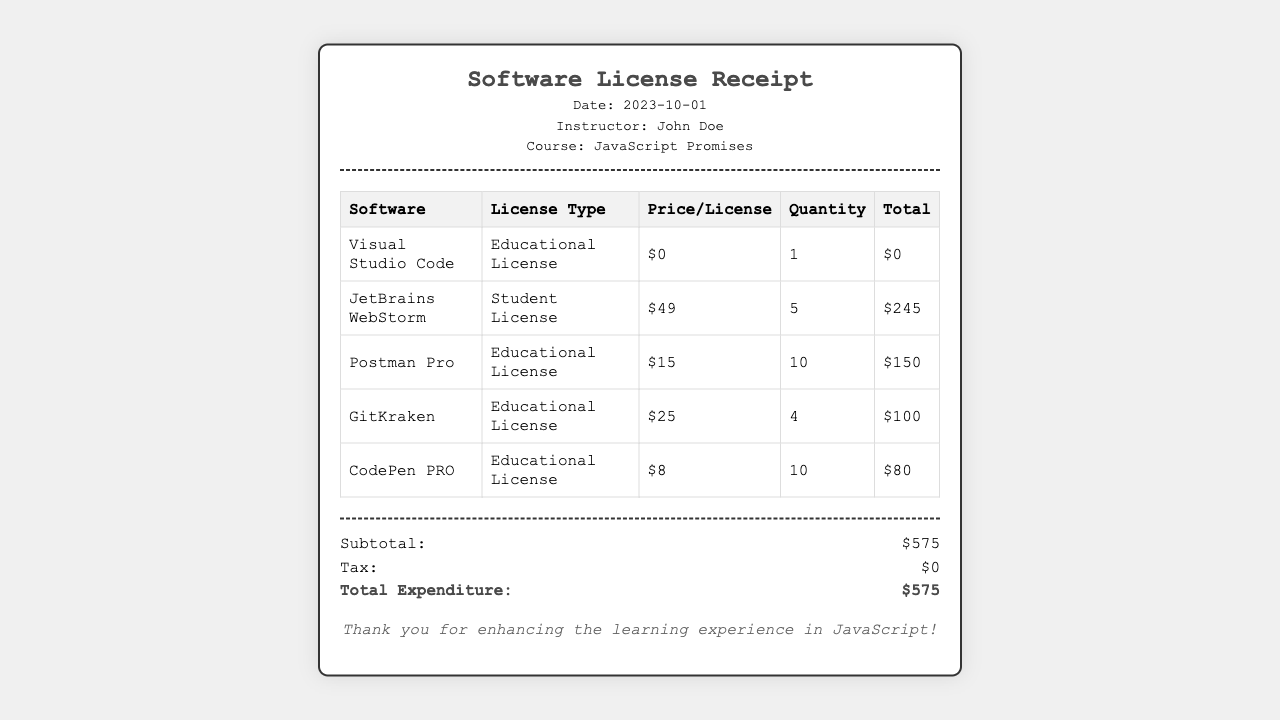what is the date of the receipt? The date is clearly stated in the header section of the document.
Answer: 2023-10-01 who is the instructor listed in the receipt? The instructor's name is displayed in the header of the receipt.
Answer: John Doe what is the total expenditure on software licenses? The total expenditure is calculated as the sum of all item totals and noted in the summary section.
Answer: $575 how many licenses of JetBrains WebStorm were purchased? The quantity of licenses is shown in the table under the respective software.
Answer: 5 what is the price per license for Postman Pro? The price per license for Postman Pro is listed in the table.
Answer: $15 which software has a price per license of $0? The software with no cost is mentioned in the table under the corresponding price column.
Answer: Visual Studio Code what is the subtotal of the purchases? The subtotal is provided as part of the summary details in the document.
Answer: $575 how many total CodePen PRO licenses were included in the purchase? The quantity is indicated in the relevant row of the table.
Answer: 10 what type of license is JetBrains WebStorm categorized as? The license type is specified next to the software name in the table.
Answer: Student License 